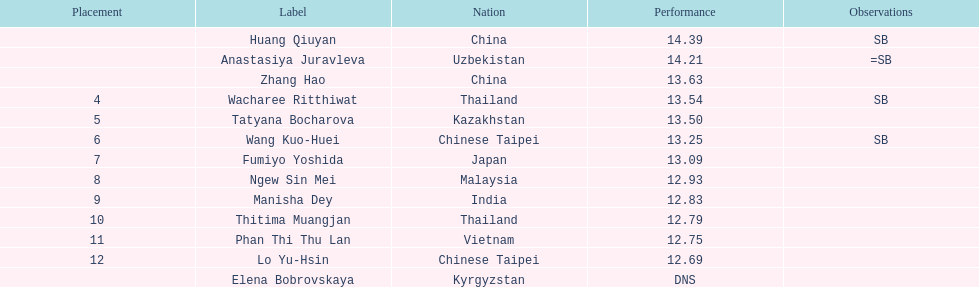How many athletes were from china? 2. 